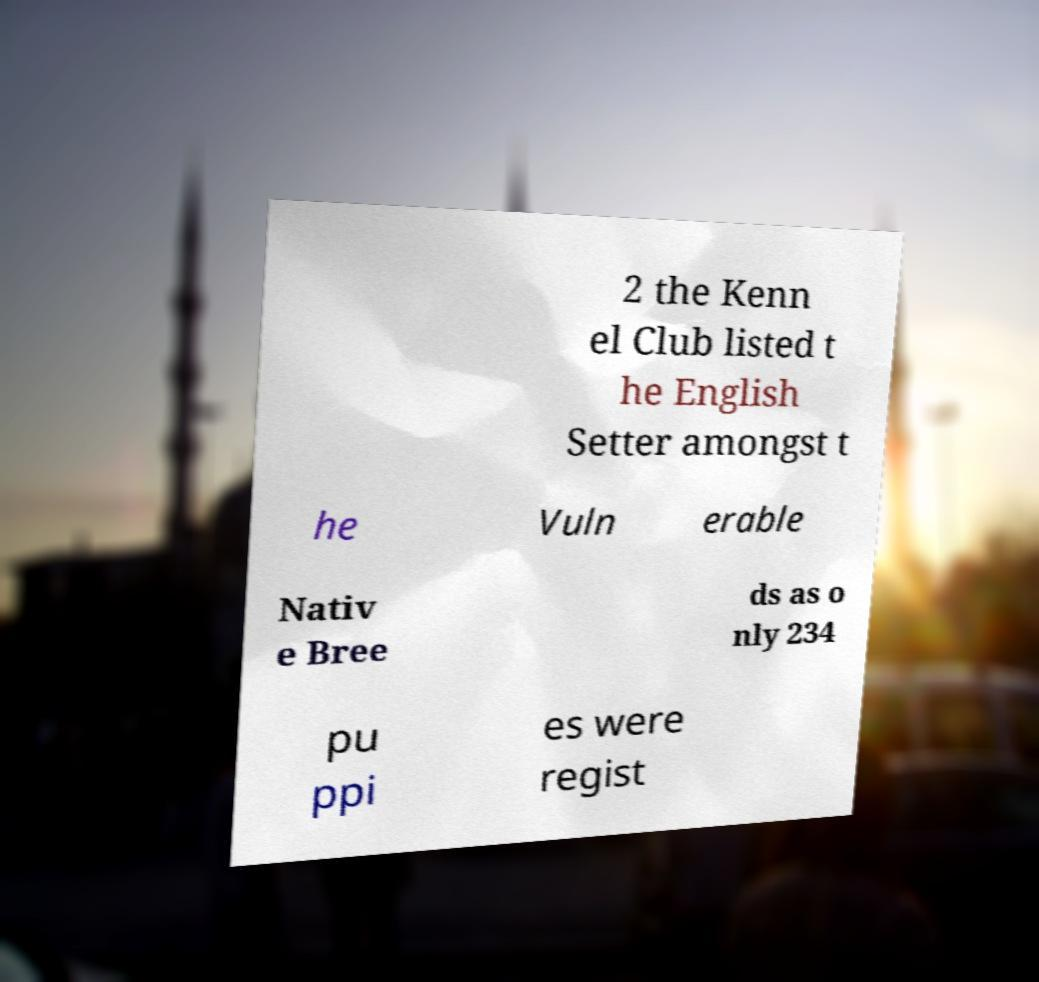Please identify and transcribe the text found in this image. 2 the Kenn el Club listed t he English Setter amongst t he Vuln erable Nativ e Bree ds as o nly 234 pu ppi es were regist 